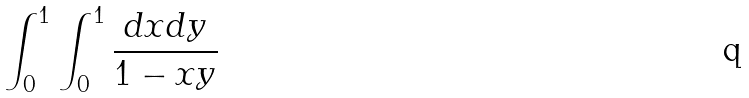Convert formula to latex. <formula><loc_0><loc_0><loc_500><loc_500>\int _ { 0 } ^ { 1 } \int _ { 0 } ^ { 1 } \frac { d x d y } { 1 - x y }</formula> 